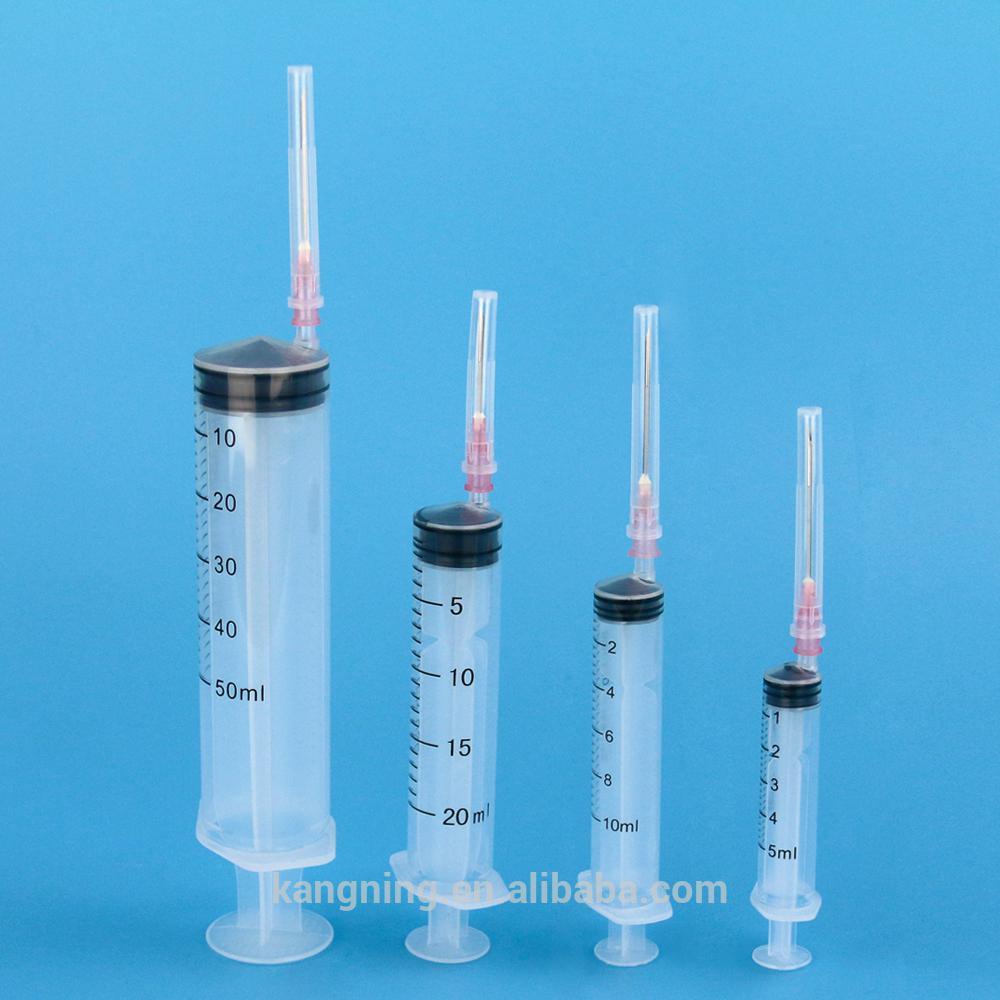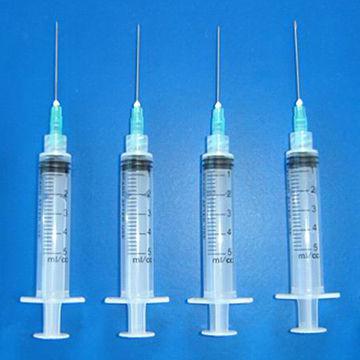The first image is the image on the left, the second image is the image on the right. For the images displayed, is the sentence "Each image contains more than four syringes." factually correct? Answer yes or no. No. 